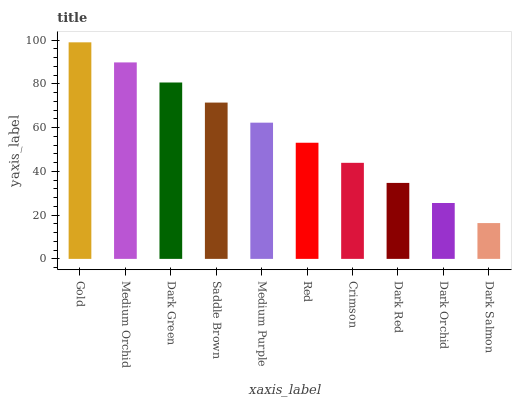Is Dark Salmon the minimum?
Answer yes or no. Yes. Is Gold the maximum?
Answer yes or no. Yes. Is Medium Orchid the minimum?
Answer yes or no. No. Is Medium Orchid the maximum?
Answer yes or no. No. Is Gold greater than Medium Orchid?
Answer yes or no. Yes. Is Medium Orchid less than Gold?
Answer yes or no. Yes. Is Medium Orchid greater than Gold?
Answer yes or no. No. Is Gold less than Medium Orchid?
Answer yes or no. No. Is Medium Purple the high median?
Answer yes or no. Yes. Is Red the low median?
Answer yes or no. Yes. Is Medium Orchid the high median?
Answer yes or no. No. Is Dark Orchid the low median?
Answer yes or no. No. 